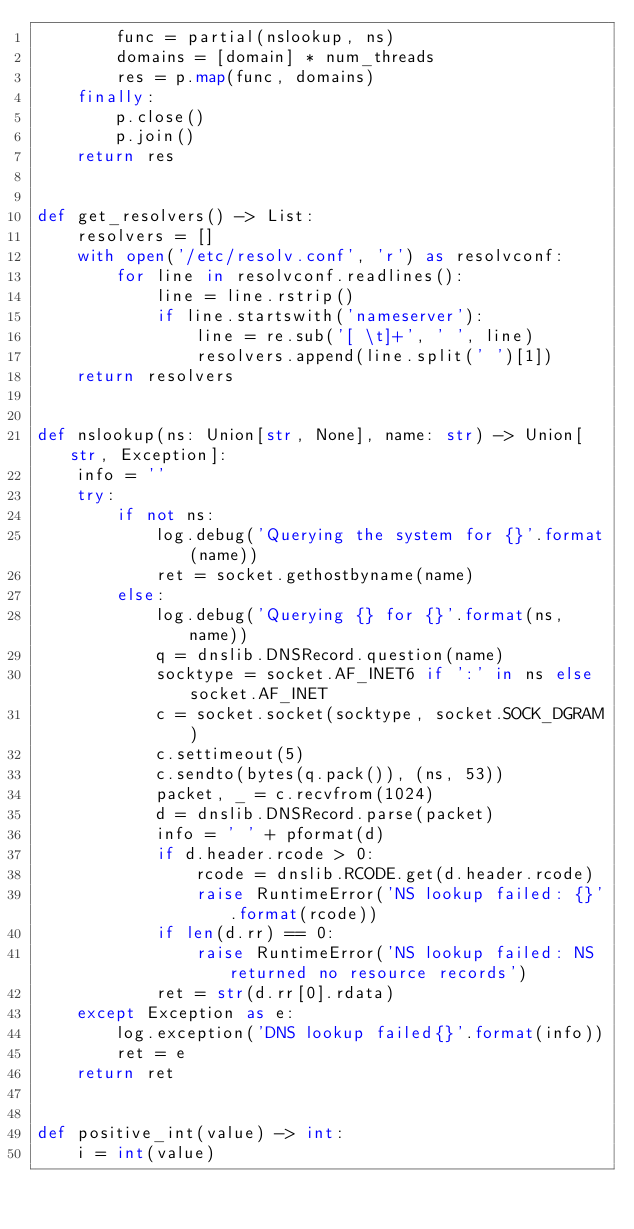<code> <loc_0><loc_0><loc_500><loc_500><_Python_>        func = partial(nslookup, ns)
        domains = [domain] * num_threads
        res = p.map(func, domains)
    finally:
        p.close()
        p.join()
    return res


def get_resolvers() -> List:
    resolvers = []
    with open('/etc/resolv.conf', 'r') as resolvconf:
        for line in resolvconf.readlines():
            line = line.rstrip()
            if line.startswith('nameserver'):
                line = re.sub('[ \t]+', ' ', line)
                resolvers.append(line.split(' ')[1])
    return resolvers


def nslookup(ns: Union[str, None], name: str) -> Union[str, Exception]:
    info = ''
    try:
        if not ns:
            log.debug('Querying the system for {}'.format(name))
            ret = socket.gethostbyname(name)
        else:
            log.debug('Querying {} for {}'.format(ns, name))
            q = dnslib.DNSRecord.question(name)
            socktype = socket.AF_INET6 if ':' in ns else socket.AF_INET
            c = socket.socket(socktype, socket.SOCK_DGRAM)
            c.settimeout(5)
            c.sendto(bytes(q.pack()), (ns, 53))
            packet, _ = c.recvfrom(1024)
            d = dnslib.DNSRecord.parse(packet)
            info = ' ' + pformat(d)
            if d.header.rcode > 0:
                rcode = dnslib.RCODE.get(d.header.rcode)
                raise RuntimeError('NS lookup failed: {}'.format(rcode))
            if len(d.rr) == 0:
                raise RuntimeError('NS lookup failed: NS returned no resource records')
            ret = str(d.rr[0].rdata)
    except Exception as e:
        log.exception('DNS lookup failed{}'.format(info))
        ret = e
    return ret


def positive_int(value) -> int:
    i = int(value)</code> 